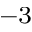<formula> <loc_0><loc_0><loc_500><loc_500>^ { - 3 }</formula> 